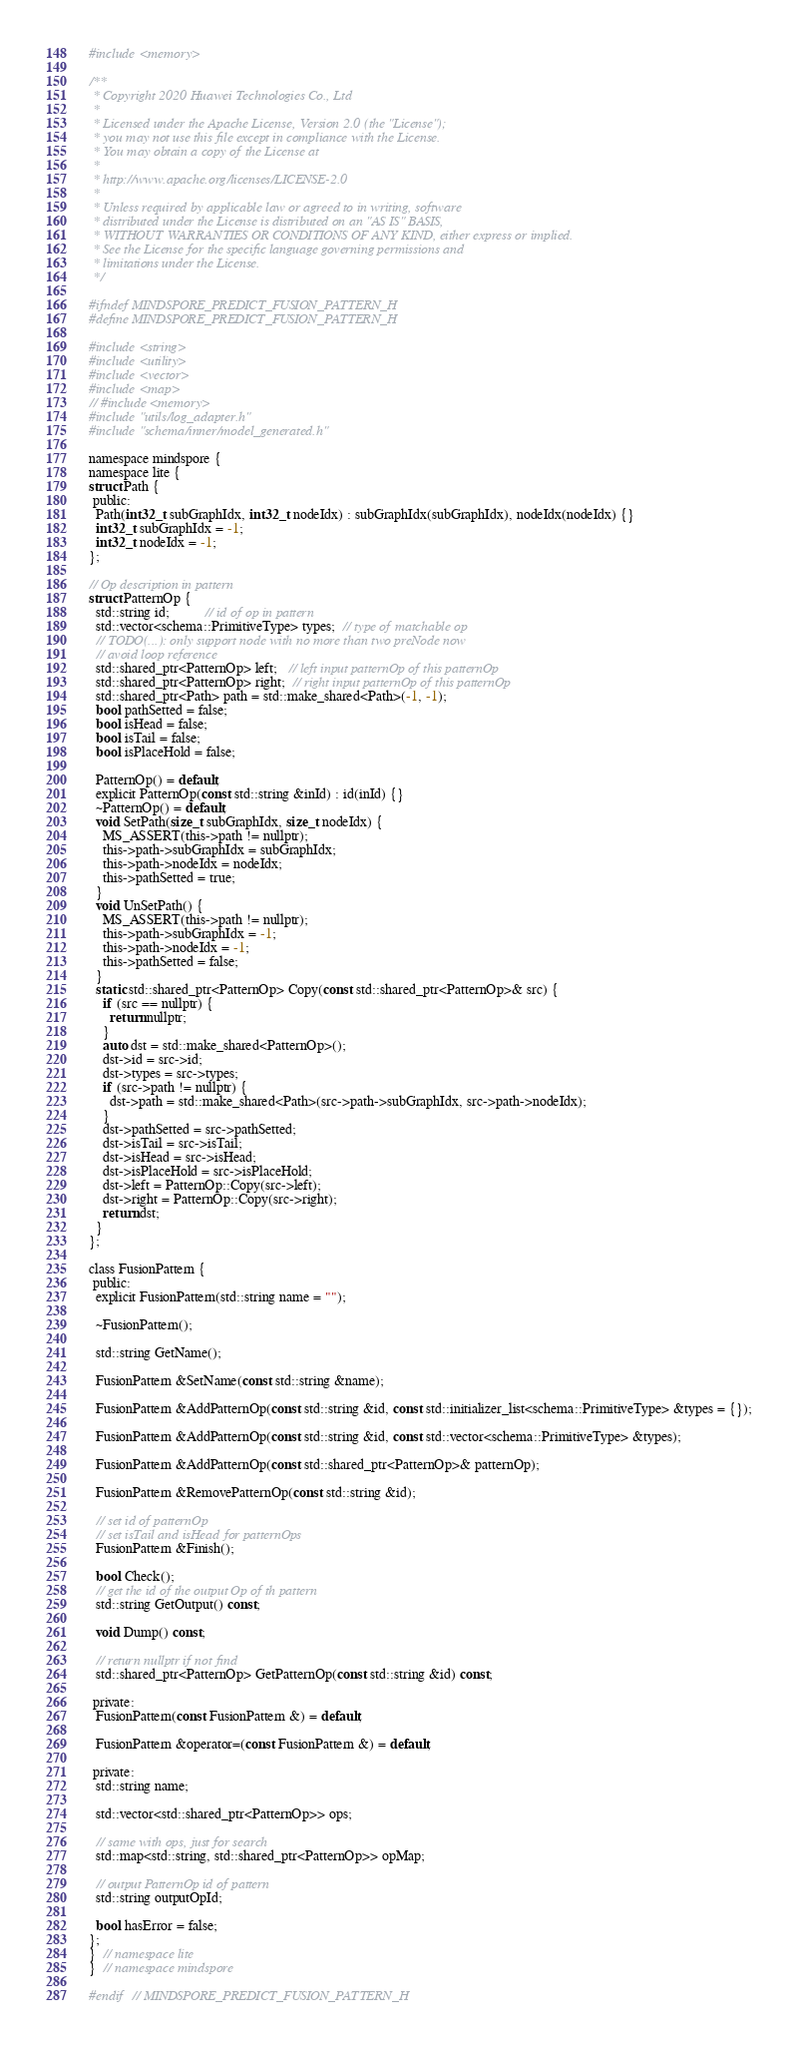Convert code to text. <code><loc_0><loc_0><loc_500><loc_500><_C_>#include <memory>

/**
 * Copyright 2020 Huawei Technologies Co., Ltd
 *
 * Licensed under the Apache License, Version 2.0 (the "License");
 * you may not use this file except in compliance with the License.
 * You may obtain a copy of the License at
 *
 * http://www.apache.org/licenses/LICENSE-2.0
 *
 * Unless required by applicable law or agreed to in writing, software
 * distributed under the License is distributed on an "AS IS" BASIS,
 * WITHOUT WARRANTIES OR CONDITIONS OF ANY KIND, either express or implied.
 * See the License for the specific language governing permissions and
 * limitations under the License.
 */

#ifndef MINDSPORE_PREDICT_FUSION_PATTERN_H
#define MINDSPORE_PREDICT_FUSION_PATTERN_H

#include <string>
#include <utility>
#include <vector>
#include <map>
// #include <memory>
#include "utils/log_adapter.h"
#include "schema/inner/model_generated.h"

namespace mindspore {
namespace lite {
struct Path {
 public:
  Path(int32_t subGraphIdx, int32_t nodeIdx) : subGraphIdx(subGraphIdx), nodeIdx(nodeIdx) {}
  int32_t subGraphIdx = -1;
  int32_t nodeIdx = -1;
};

// Op description in pattern
struct PatternOp {
  std::string id;          // id of op in pattern
  std::vector<schema::PrimitiveType> types;  // type of matchable op
  // TODO(...): only support node with no more than two preNode now
  // avoid loop reference
  std::shared_ptr<PatternOp> left;   // left input patternOp of this patternOp
  std::shared_ptr<PatternOp> right;  // right input patternOp of this patternOp
  std::shared_ptr<Path> path = std::make_shared<Path>(-1, -1);
  bool pathSetted = false;
  bool isHead = false;
  bool isTail = false;
  bool isPlaceHold = false;

  PatternOp() = default;
  explicit PatternOp(const std::string &inId) : id(inId) {}
  ~PatternOp() = default;
  void SetPath(size_t subGraphIdx, size_t nodeIdx) {
    MS_ASSERT(this->path != nullptr);
    this->path->subGraphIdx = subGraphIdx;
    this->path->nodeIdx = nodeIdx;
    this->pathSetted = true;
  }
  void UnSetPath() {
    MS_ASSERT(this->path != nullptr);
    this->path->subGraphIdx = -1;
    this->path->nodeIdx = -1;
    this->pathSetted = false;
  }
  static std::shared_ptr<PatternOp> Copy(const std::shared_ptr<PatternOp>& src) {
    if (src == nullptr) {
      return nullptr;
    }
    auto dst = std::make_shared<PatternOp>();
    dst->id = src->id;
    dst->types = src->types;
    if (src->path != nullptr) {
      dst->path = std::make_shared<Path>(src->path->subGraphIdx, src->path->nodeIdx);
    }
    dst->pathSetted = src->pathSetted;
    dst->isTail = src->isTail;
    dst->isHead = src->isHead;
    dst->isPlaceHold = src->isPlaceHold;
    dst->left = PatternOp::Copy(src->left);
    dst->right = PatternOp::Copy(src->right);
    return dst;
  }
};

class FusionPattern {
 public:
  explicit FusionPattern(std::string name = "");

  ~FusionPattern();

  std::string GetName();

  FusionPattern &SetName(const std::string &name);

  FusionPattern &AddPatternOp(const std::string &id, const std::initializer_list<schema::PrimitiveType> &types = {});

  FusionPattern &AddPatternOp(const std::string &id, const std::vector<schema::PrimitiveType> &types);

  FusionPattern &AddPatternOp(const std::shared_ptr<PatternOp>& patternOp);

  FusionPattern &RemovePatternOp(const std::string &id);

  // set id of patternOp
  // set isTail and isHead for patternOps
  FusionPattern &Finish();

  bool Check();
  // get the id of the output Op of th pattern
  std::string GetOutput() const;

  void Dump() const;

  // return nullptr if not find
  std::shared_ptr<PatternOp> GetPatternOp(const std::string &id) const;

 private:
  FusionPattern(const FusionPattern &) = default;

  FusionPattern &operator=(const FusionPattern &) = default;

 private:
  std::string name;

  std::vector<std::shared_ptr<PatternOp>> ops;

  // same with ops, just for search
  std::map<std::string, std::shared_ptr<PatternOp>> opMap;

  // output PatternOp id of pattern
  std::string outputOpId;

  bool hasError = false;
};
}  // namespace lite
}  // namespace mindspore

#endif  // MINDSPORE_PREDICT_FUSION_PATTERN_H

</code> 